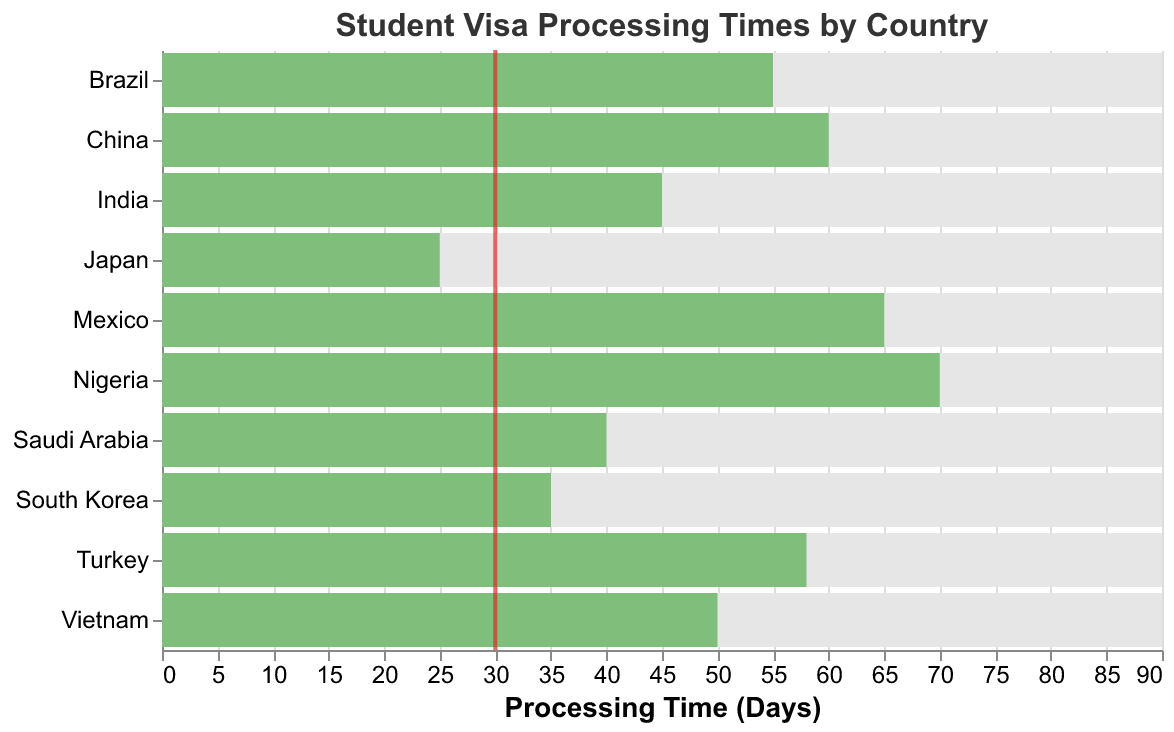What is the title of the figure? The title is located at the top of the figure and typically describes the overall content. Here, the title is "Student Visa Processing Times by Country."
Answer: "Student Visa Processing Times by Country" How many countries have an actual processing time that exceeds the target processing time? The actual processing time is shown by the green bars, and the target processing time is indicated by red ticks. Count the number of countries where the green bar extends beyond the red tick.
Answer: 9 Which country has the shortest actual visa processing time? Look for the country with the shortest green bar indicating the actual processing time. Here, Japan has the shortest green bar.
Answer: Japan By how many days does the visa processing time for Mexico exceed the target processing time? Locate Mexico's green bar (Actual: 65 days) and its red tick (Target: 30 days), then subtract the target from the actual processing time (65 - 30).
Answer: 35 Which country is closest to meeting the target processing time? Find which country has its green bar closest to the red tick. South Korea has an actual processing time of 35 days with a target of 30 days, which is the closest among the rest.
Answer: South Korea Which countries have an actual processing time longer than 50 days? Identify the green bars that extend beyond 50 days on the x-axis. These countries are China (60 days), Brazil (55 days), Nigeria (70 days), Vietnam (50 days), Mexico (65 days), and Turkey (58 days).
Answer: China, Brazil, Nigeria, Vietnam, Mexico, Turkey What is the average actual processing time for all countries? Sum the actual processing times for all countries (60 + 45 + 35 + 55 + 70 + 40 + 50 + 25 + 65 + 58) and divide by the number of countries, which is 10. The calculation is (503 / 10).
Answer: 50.3 How much longer is the actual processing time for Nigeria compared to India? Subtract India's actual processing time (45 days) from Nigeria's actual processing time (70 days).
Answer: 25 What is the overall range of visa processing times in the dataset? Determine the difference between the maximum actual processing time (Nigeria with 70 days) and the minimum actual processing time (Japan with 25 days). Subtract the minimum from the maximum (70 - 25).
Answer: 45 days 